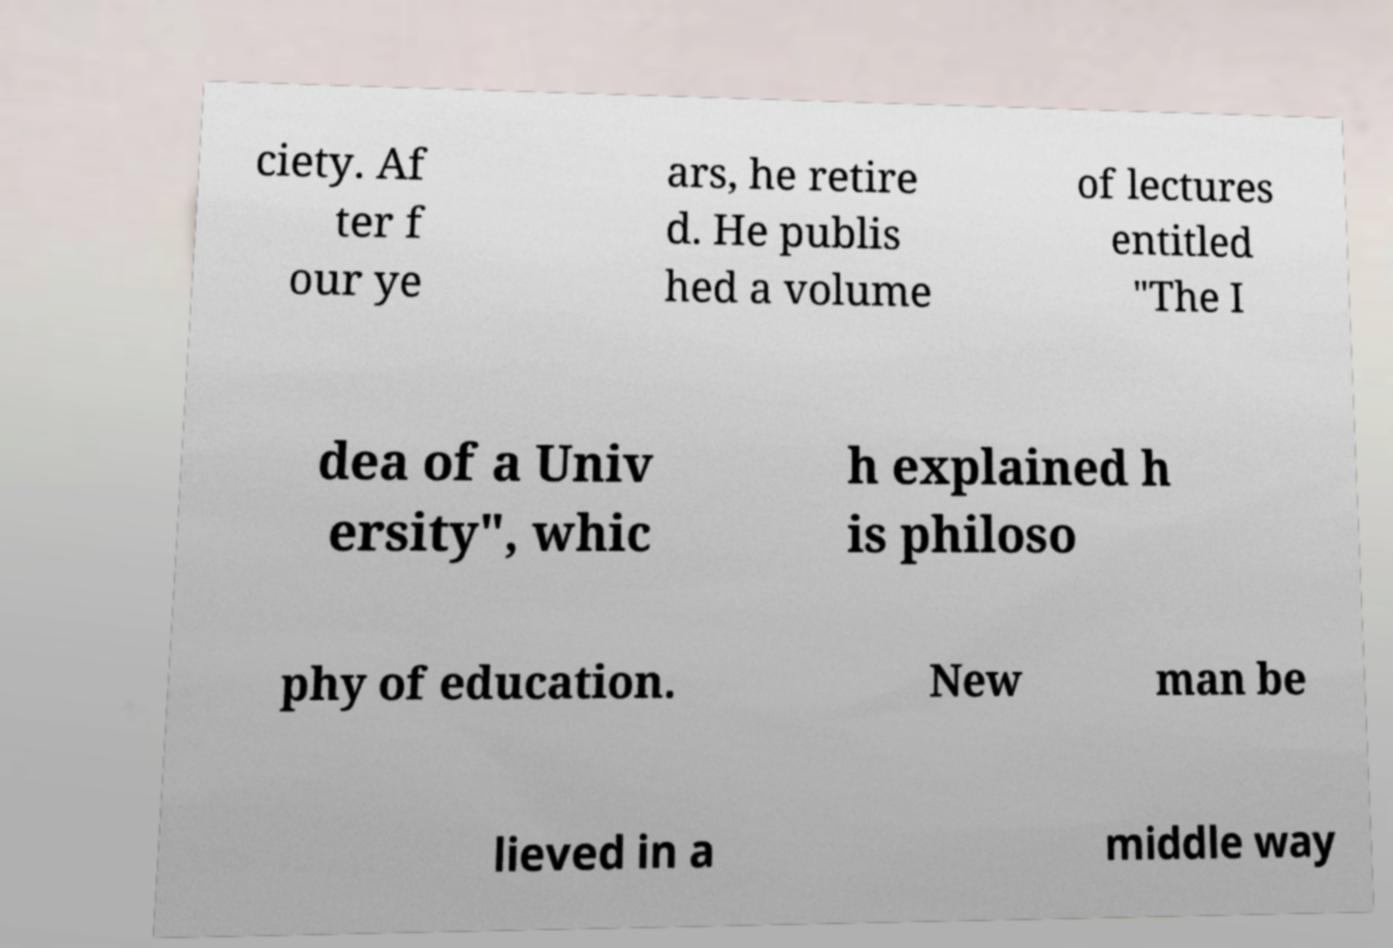For documentation purposes, I need the text within this image transcribed. Could you provide that? ciety. Af ter f our ye ars, he retire d. He publis hed a volume of lectures entitled "The I dea of a Univ ersity", whic h explained h is philoso phy of education. New man be lieved in a middle way 